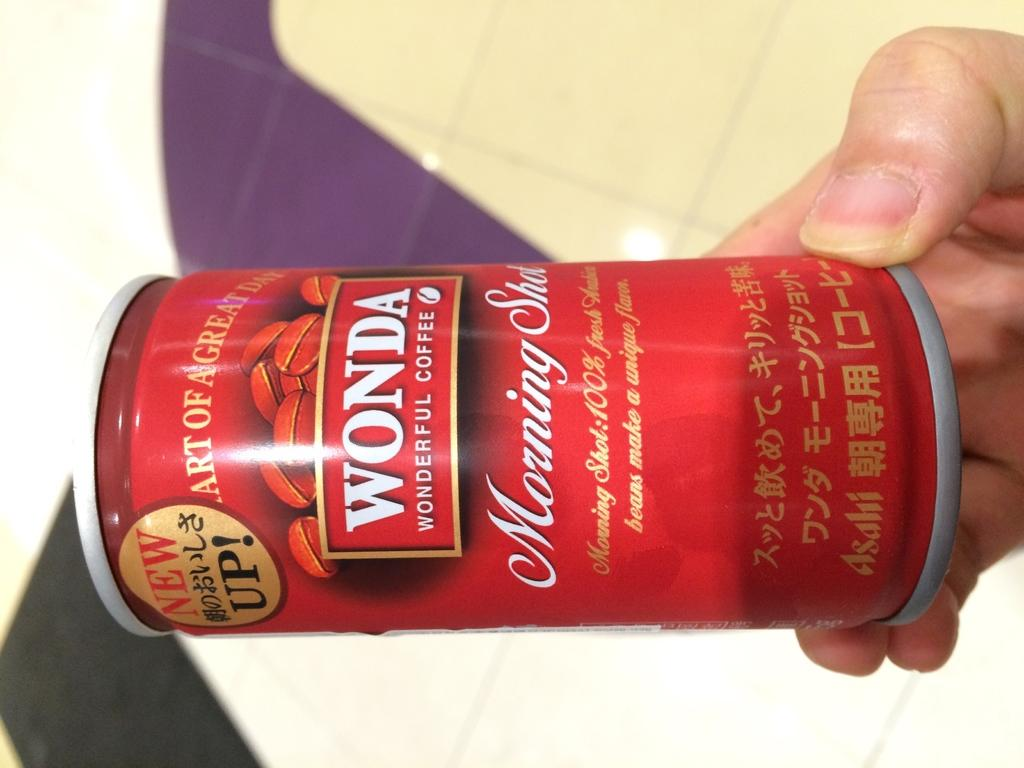Provide a one-sentence caption for the provided image. A red can of Wonda wonderful coffee is being held up by a hand. 